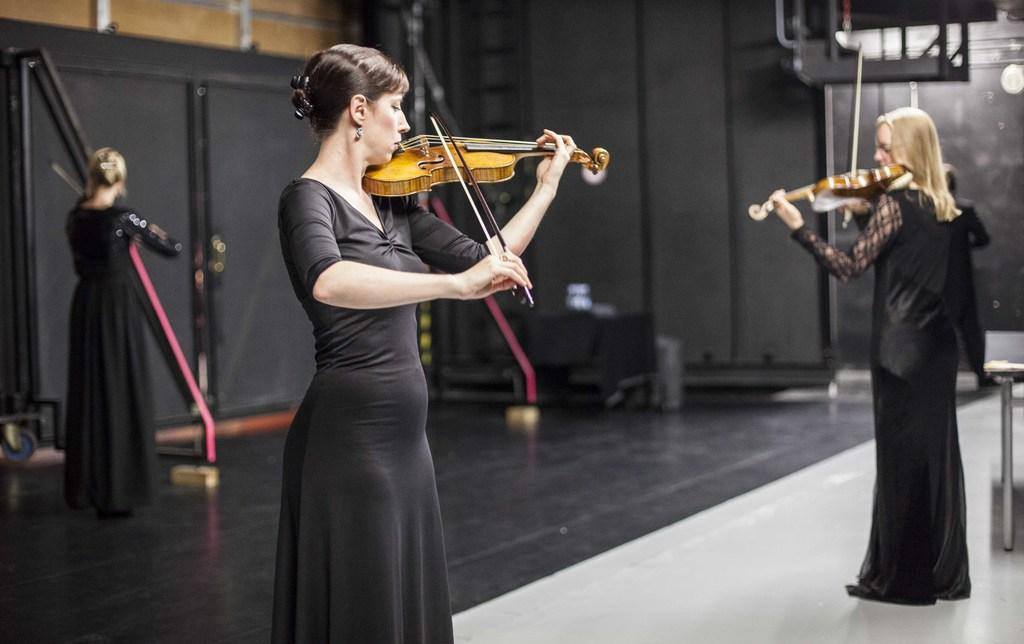How many women are in the image? There are three women in the image. What are the women doing in the image? The women are standing and playing violins. Can you describe the arrangement of the women in the image? The women are at a distance from each other. What other objects can be seen in the room? There is a cupboard and a pole near the cupboard. What type of leg is visible in the image? There is no leg visible in the image; it features three women playing violins and other objects in the room. Is there an oven present in the image? No, there is no oven present in the image. 